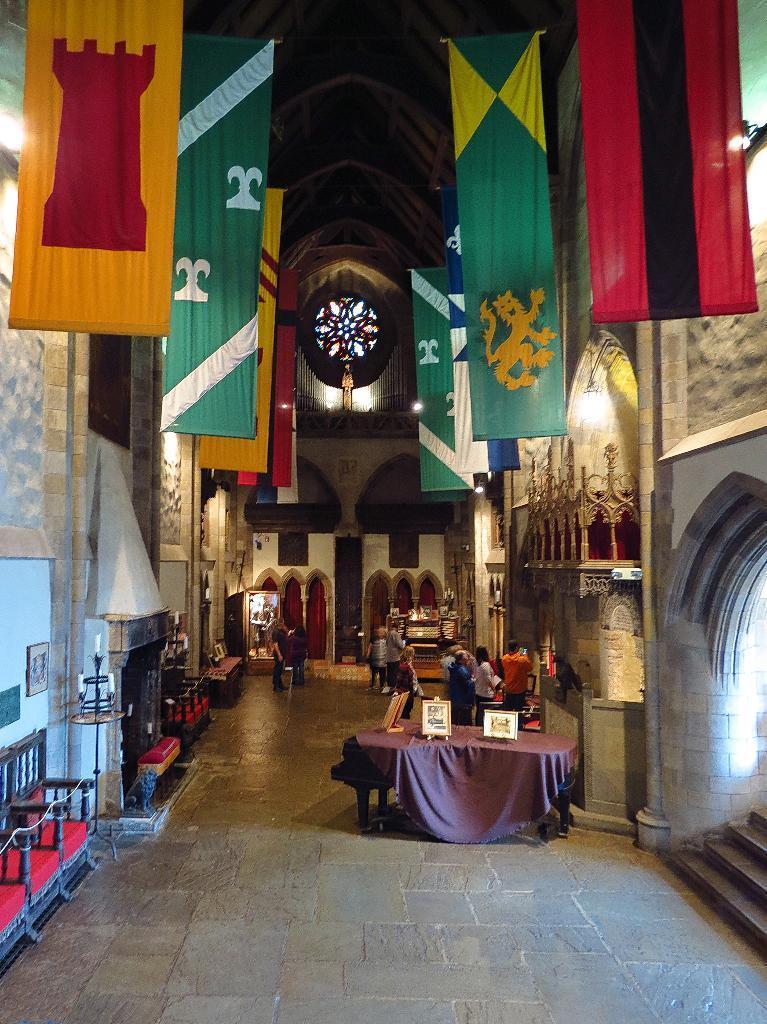Can you describe this image briefly? On the left side, there are flags attached to the wall of the building. On the right side, there are photo frames on the table, there are flags attached to the wall of the building. In the background, there are persons on the floor. And the background is dark in color. 